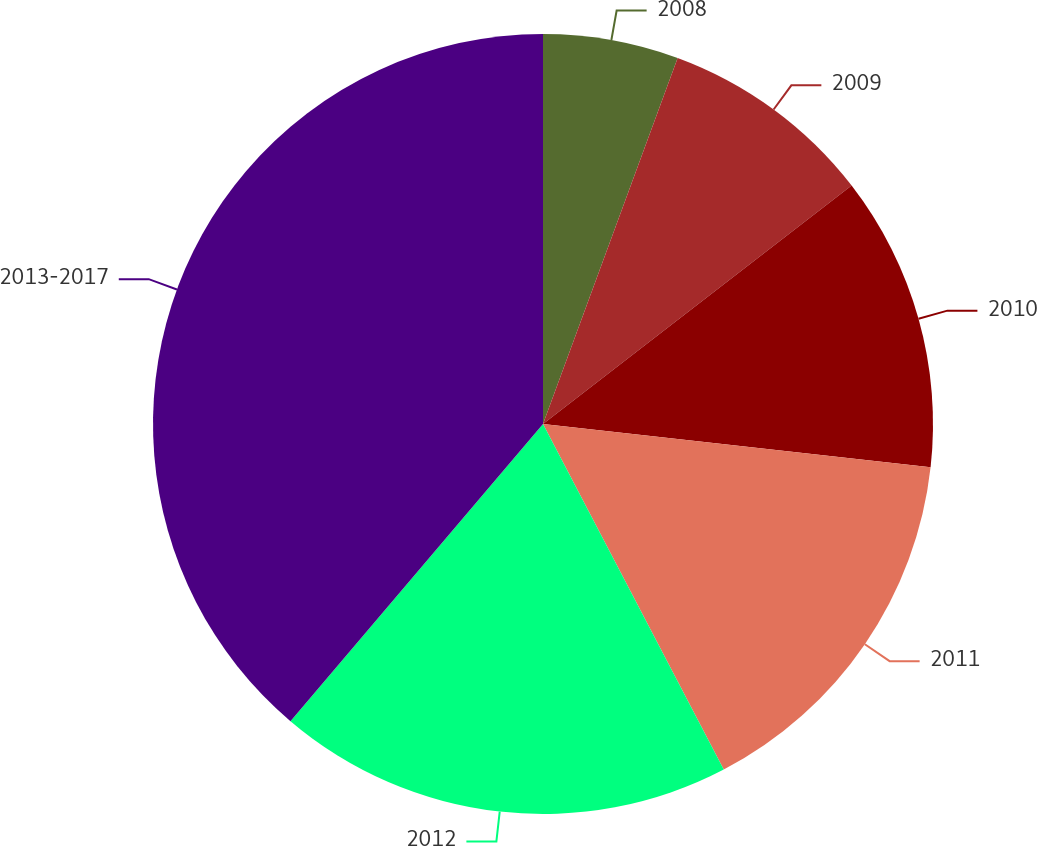Convert chart. <chart><loc_0><loc_0><loc_500><loc_500><pie_chart><fcel>2008<fcel>2009<fcel>2010<fcel>2011<fcel>2012<fcel>2013-2017<nl><fcel>5.61%<fcel>8.92%<fcel>12.24%<fcel>15.56%<fcel>18.88%<fcel>38.79%<nl></chart> 